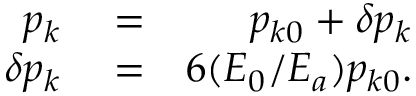Convert formula to latex. <formula><loc_0><loc_0><loc_500><loc_500>\begin{array} { r l r } { p _ { k } } & = } & { p _ { k 0 } + \delta p _ { k } } \\ { \delta p _ { k } } & = } & { 6 ( E _ { 0 } / E _ { a } ) p _ { k 0 } . } \end{array}</formula> 